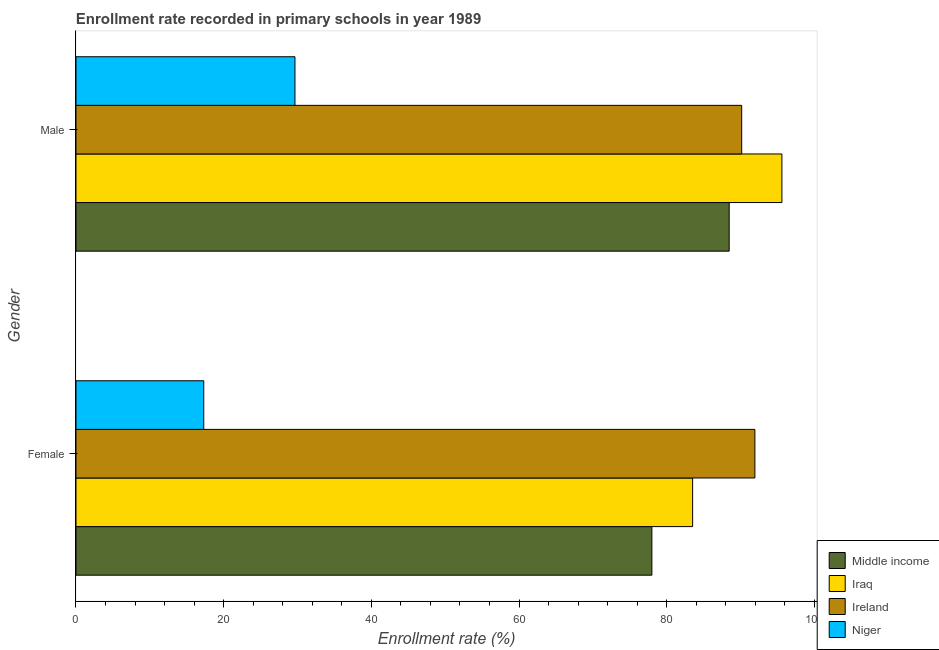How many different coloured bars are there?
Your answer should be compact. 4. How many bars are there on the 2nd tick from the bottom?
Your response must be concise. 4. What is the label of the 2nd group of bars from the top?
Offer a terse response. Female. What is the enrollment rate of male students in Ireland?
Your response must be concise. 90.15. Across all countries, what is the maximum enrollment rate of female students?
Give a very brief answer. 91.94. Across all countries, what is the minimum enrollment rate of male students?
Ensure brevity in your answer.  29.65. In which country was the enrollment rate of female students maximum?
Offer a terse response. Ireland. In which country was the enrollment rate of female students minimum?
Provide a succinct answer. Niger. What is the total enrollment rate of female students in the graph?
Ensure brevity in your answer.  270.73. What is the difference between the enrollment rate of female students in Middle income and that in Ireland?
Give a very brief answer. -13.95. What is the difference between the enrollment rate of male students in Ireland and the enrollment rate of female students in Iraq?
Your answer should be compact. 6.64. What is the average enrollment rate of female students per country?
Give a very brief answer. 67.68. What is the difference between the enrollment rate of male students and enrollment rate of female students in Niger?
Provide a short and direct response. 12.35. What is the ratio of the enrollment rate of female students in Niger to that in Ireland?
Provide a short and direct response. 0.19. In how many countries, is the enrollment rate of male students greater than the average enrollment rate of male students taken over all countries?
Ensure brevity in your answer.  3. What does the 1st bar from the top in Female represents?
Make the answer very short. Niger. How many bars are there?
Offer a terse response. 8. How many countries are there in the graph?
Make the answer very short. 4. What is the difference between two consecutive major ticks on the X-axis?
Your response must be concise. 20. Are the values on the major ticks of X-axis written in scientific E-notation?
Keep it short and to the point. No. Does the graph contain grids?
Keep it short and to the point. No. Where does the legend appear in the graph?
Provide a succinct answer. Bottom right. How many legend labels are there?
Ensure brevity in your answer.  4. How are the legend labels stacked?
Make the answer very short. Vertical. What is the title of the graph?
Offer a very short reply. Enrollment rate recorded in primary schools in year 1989. What is the label or title of the X-axis?
Ensure brevity in your answer.  Enrollment rate (%). What is the label or title of the Y-axis?
Keep it short and to the point. Gender. What is the Enrollment rate (%) in Middle income in Female?
Offer a terse response. 77.99. What is the Enrollment rate (%) in Iraq in Female?
Make the answer very short. 83.51. What is the Enrollment rate (%) of Ireland in Female?
Offer a terse response. 91.94. What is the Enrollment rate (%) of Niger in Female?
Ensure brevity in your answer.  17.3. What is the Enrollment rate (%) of Middle income in Male?
Your response must be concise. 88.46. What is the Enrollment rate (%) of Iraq in Male?
Your answer should be very brief. 95.6. What is the Enrollment rate (%) in Ireland in Male?
Offer a very short reply. 90.15. What is the Enrollment rate (%) in Niger in Male?
Your response must be concise. 29.65. Across all Gender, what is the maximum Enrollment rate (%) of Middle income?
Your response must be concise. 88.46. Across all Gender, what is the maximum Enrollment rate (%) in Iraq?
Offer a very short reply. 95.6. Across all Gender, what is the maximum Enrollment rate (%) in Ireland?
Keep it short and to the point. 91.94. Across all Gender, what is the maximum Enrollment rate (%) in Niger?
Offer a terse response. 29.65. Across all Gender, what is the minimum Enrollment rate (%) in Middle income?
Your answer should be compact. 77.99. Across all Gender, what is the minimum Enrollment rate (%) of Iraq?
Provide a succinct answer. 83.51. Across all Gender, what is the minimum Enrollment rate (%) in Ireland?
Your answer should be very brief. 90.15. Across all Gender, what is the minimum Enrollment rate (%) in Niger?
Ensure brevity in your answer.  17.3. What is the total Enrollment rate (%) in Middle income in the graph?
Ensure brevity in your answer.  166.45. What is the total Enrollment rate (%) of Iraq in the graph?
Provide a short and direct response. 179.1. What is the total Enrollment rate (%) in Ireland in the graph?
Ensure brevity in your answer.  182.09. What is the total Enrollment rate (%) of Niger in the graph?
Provide a short and direct response. 46.96. What is the difference between the Enrollment rate (%) in Middle income in Female and that in Male?
Your response must be concise. -10.47. What is the difference between the Enrollment rate (%) in Iraq in Female and that in Male?
Give a very brief answer. -12.09. What is the difference between the Enrollment rate (%) in Ireland in Female and that in Male?
Offer a terse response. 1.79. What is the difference between the Enrollment rate (%) of Niger in Female and that in Male?
Provide a succinct answer. -12.35. What is the difference between the Enrollment rate (%) in Middle income in Female and the Enrollment rate (%) in Iraq in Male?
Offer a very short reply. -17.61. What is the difference between the Enrollment rate (%) in Middle income in Female and the Enrollment rate (%) in Ireland in Male?
Make the answer very short. -12.16. What is the difference between the Enrollment rate (%) in Middle income in Female and the Enrollment rate (%) in Niger in Male?
Make the answer very short. 48.33. What is the difference between the Enrollment rate (%) in Iraq in Female and the Enrollment rate (%) in Ireland in Male?
Provide a succinct answer. -6.64. What is the difference between the Enrollment rate (%) of Iraq in Female and the Enrollment rate (%) of Niger in Male?
Keep it short and to the point. 53.85. What is the difference between the Enrollment rate (%) in Ireland in Female and the Enrollment rate (%) in Niger in Male?
Keep it short and to the point. 62.28. What is the average Enrollment rate (%) in Middle income per Gender?
Offer a very short reply. 83.22. What is the average Enrollment rate (%) of Iraq per Gender?
Keep it short and to the point. 89.55. What is the average Enrollment rate (%) of Ireland per Gender?
Offer a terse response. 91.04. What is the average Enrollment rate (%) of Niger per Gender?
Give a very brief answer. 23.48. What is the difference between the Enrollment rate (%) in Middle income and Enrollment rate (%) in Iraq in Female?
Ensure brevity in your answer.  -5.52. What is the difference between the Enrollment rate (%) in Middle income and Enrollment rate (%) in Ireland in Female?
Your answer should be very brief. -13.95. What is the difference between the Enrollment rate (%) in Middle income and Enrollment rate (%) in Niger in Female?
Offer a very short reply. 60.68. What is the difference between the Enrollment rate (%) of Iraq and Enrollment rate (%) of Ireland in Female?
Offer a terse response. -8.43. What is the difference between the Enrollment rate (%) of Iraq and Enrollment rate (%) of Niger in Female?
Give a very brief answer. 66.2. What is the difference between the Enrollment rate (%) in Ireland and Enrollment rate (%) in Niger in Female?
Provide a succinct answer. 74.63. What is the difference between the Enrollment rate (%) of Middle income and Enrollment rate (%) of Iraq in Male?
Your answer should be very brief. -7.14. What is the difference between the Enrollment rate (%) of Middle income and Enrollment rate (%) of Ireland in Male?
Provide a succinct answer. -1.69. What is the difference between the Enrollment rate (%) in Middle income and Enrollment rate (%) in Niger in Male?
Provide a succinct answer. 58.8. What is the difference between the Enrollment rate (%) of Iraq and Enrollment rate (%) of Ireland in Male?
Make the answer very short. 5.45. What is the difference between the Enrollment rate (%) of Iraq and Enrollment rate (%) of Niger in Male?
Keep it short and to the point. 65.94. What is the difference between the Enrollment rate (%) in Ireland and Enrollment rate (%) in Niger in Male?
Your answer should be very brief. 60.5. What is the ratio of the Enrollment rate (%) in Middle income in Female to that in Male?
Ensure brevity in your answer.  0.88. What is the ratio of the Enrollment rate (%) in Iraq in Female to that in Male?
Keep it short and to the point. 0.87. What is the ratio of the Enrollment rate (%) in Ireland in Female to that in Male?
Make the answer very short. 1.02. What is the ratio of the Enrollment rate (%) in Niger in Female to that in Male?
Make the answer very short. 0.58. What is the difference between the highest and the second highest Enrollment rate (%) of Middle income?
Your response must be concise. 10.47. What is the difference between the highest and the second highest Enrollment rate (%) of Iraq?
Give a very brief answer. 12.09. What is the difference between the highest and the second highest Enrollment rate (%) of Ireland?
Offer a very short reply. 1.79. What is the difference between the highest and the second highest Enrollment rate (%) in Niger?
Keep it short and to the point. 12.35. What is the difference between the highest and the lowest Enrollment rate (%) of Middle income?
Offer a terse response. 10.47. What is the difference between the highest and the lowest Enrollment rate (%) in Iraq?
Offer a terse response. 12.09. What is the difference between the highest and the lowest Enrollment rate (%) in Ireland?
Keep it short and to the point. 1.79. What is the difference between the highest and the lowest Enrollment rate (%) in Niger?
Make the answer very short. 12.35. 